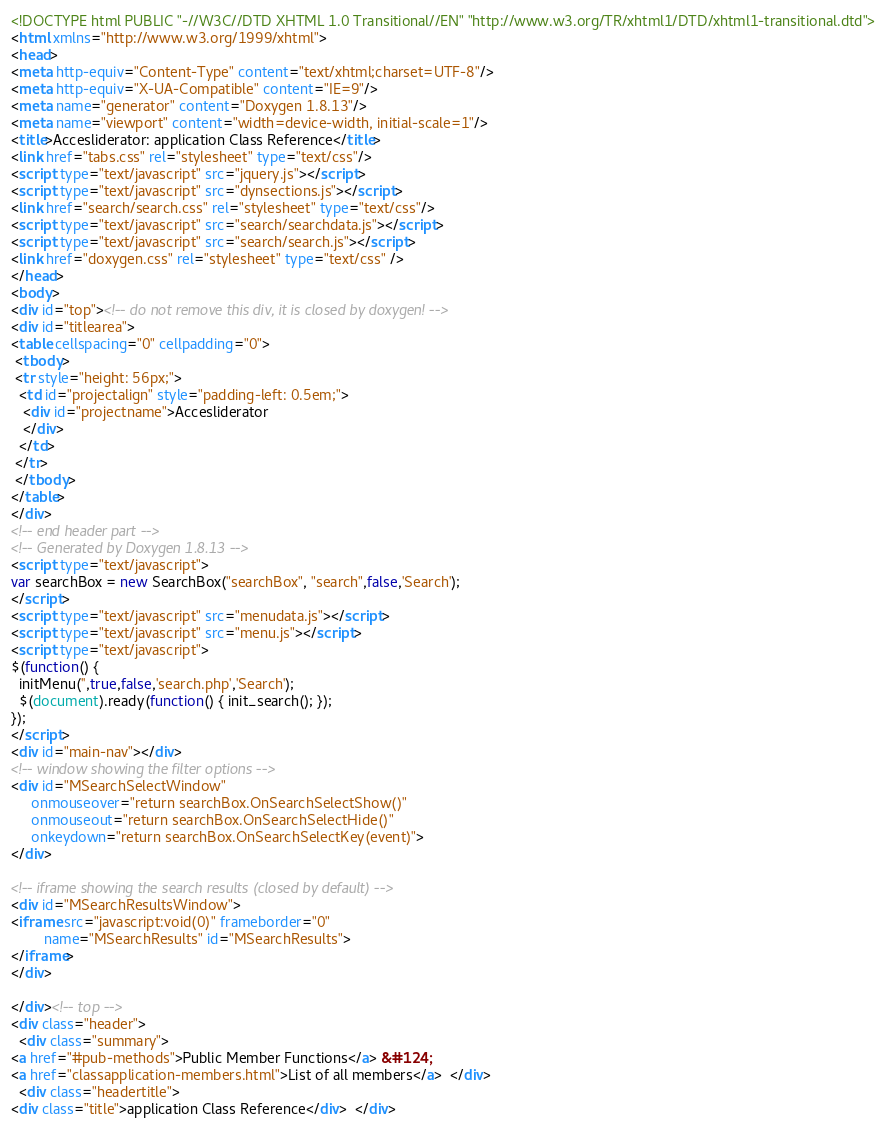Convert code to text. <code><loc_0><loc_0><loc_500><loc_500><_HTML_><!DOCTYPE html PUBLIC "-//W3C//DTD XHTML 1.0 Transitional//EN" "http://www.w3.org/TR/xhtml1/DTD/xhtml1-transitional.dtd">
<html xmlns="http://www.w3.org/1999/xhtml">
<head>
<meta http-equiv="Content-Type" content="text/xhtml;charset=UTF-8"/>
<meta http-equiv="X-UA-Compatible" content="IE=9"/>
<meta name="generator" content="Doxygen 1.8.13"/>
<meta name="viewport" content="width=device-width, initial-scale=1"/>
<title>Accesliderator: application Class Reference</title>
<link href="tabs.css" rel="stylesheet" type="text/css"/>
<script type="text/javascript" src="jquery.js"></script>
<script type="text/javascript" src="dynsections.js"></script>
<link href="search/search.css" rel="stylesheet" type="text/css"/>
<script type="text/javascript" src="search/searchdata.js"></script>
<script type="text/javascript" src="search/search.js"></script>
<link href="doxygen.css" rel="stylesheet" type="text/css" />
</head>
<body>
<div id="top"><!-- do not remove this div, it is closed by doxygen! -->
<div id="titlearea">
<table cellspacing="0" cellpadding="0">
 <tbody>
 <tr style="height: 56px;">
  <td id="projectalign" style="padding-left: 0.5em;">
   <div id="projectname">Accesliderator
   </div>
  </td>
 </tr>
 </tbody>
</table>
</div>
<!-- end header part -->
<!-- Generated by Doxygen 1.8.13 -->
<script type="text/javascript">
var searchBox = new SearchBox("searchBox", "search",false,'Search');
</script>
<script type="text/javascript" src="menudata.js"></script>
<script type="text/javascript" src="menu.js"></script>
<script type="text/javascript">
$(function() {
  initMenu('',true,false,'search.php','Search');
  $(document).ready(function() { init_search(); });
});
</script>
<div id="main-nav"></div>
<!-- window showing the filter options -->
<div id="MSearchSelectWindow"
     onmouseover="return searchBox.OnSearchSelectShow()"
     onmouseout="return searchBox.OnSearchSelectHide()"
     onkeydown="return searchBox.OnSearchSelectKey(event)">
</div>

<!-- iframe showing the search results (closed by default) -->
<div id="MSearchResultsWindow">
<iframe src="javascript:void(0)" frameborder="0" 
        name="MSearchResults" id="MSearchResults">
</iframe>
</div>

</div><!-- top -->
<div class="header">
  <div class="summary">
<a href="#pub-methods">Public Member Functions</a> &#124;
<a href="classapplication-members.html">List of all members</a>  </div>
  <div class="headertitle">
<div class="title">application Class Reference</div>  </div></code> 